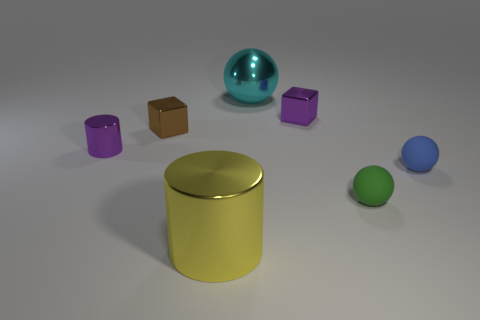Is the material of the tiny thing that is in front of the small blue rubber object the same as the tiny thing that is to the right of the tiny green rubber thing?
Provide a short and direct response. Yes. Are there any tiny rubber cylinders?
Keep it short and to the point. No. Is the number of tiny brown objects to the right of the small blue rubber ball greater than the number of yellow objects to the right of the large cyan thing?
Make the answer very short. No. What material is the cyan thing that is the same shape as the blue matte object?
Make the answer very short. Metal. Are there any other things that have the same size as the purple metallic cube?
Provide a succinct answer. Yes. There is a big object behind the blue matte ball; does it have the same color as the shiny cylinder in front of the tiny cylinder?
Make the answer very short. No. What is the shape of the small blue matte thing?
Your response must be concise. Sphere. Are there more purple metal objects left of the big cyan shiny ball than yellow things?
Make the answer very short. No. What is the shape of the large shiny object that is in front of the small metallic cylinder?
Make the answer very short. Cylinder. What number of other things are there of the same shape as the big yellow metal object?
Keep it short and to the point. 1. 